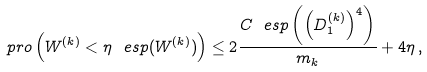<formula> <loc_0><loc_0><loc_500><loc_500>\ p r o \left ( W ^ { ( k ) } < \eta \ e s p ( W ^ { ( k ) } ) \right ) \leq 2 \frac { C \ e s p \left ( \left ( D _ { 1 } ^ { ( k ) } \right ) ^ { 4 } \right ) } { m _ { k } } + 4 \eta \, ,</formula> 